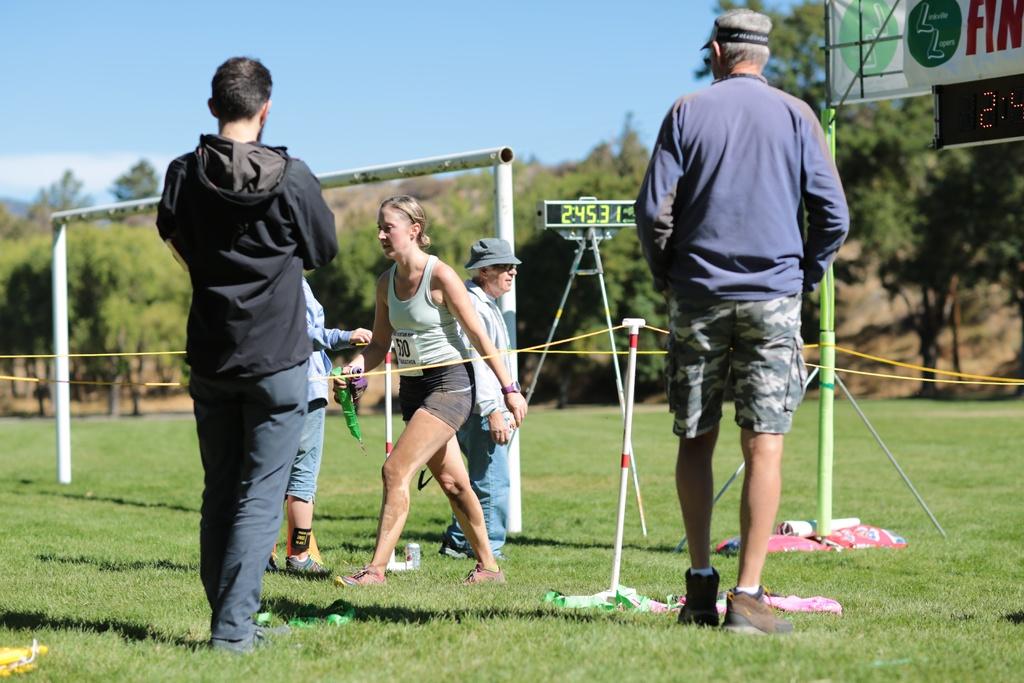What time is shown in this picture?
Offer a very short reply. 2:45:31. What is the womans number?
Offer a terse response. 530. 